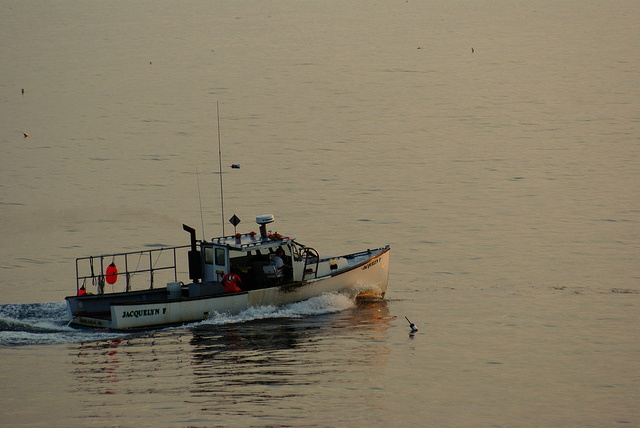Describe the objects in this image and their specific colors. I can see boat in gray and black tones, people in gray, black, purple, navy, and blue tones, and people in gray, black, maroon, and darkgreen tones in this image. 